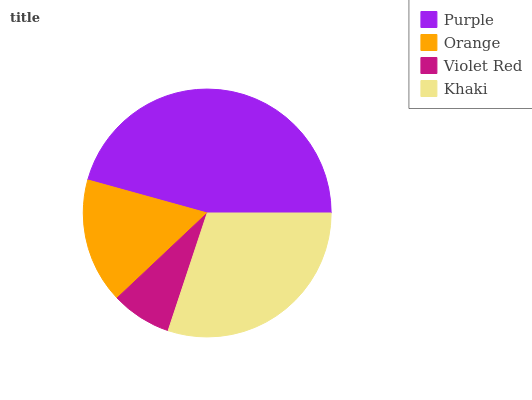Is Violet Red the minimum?
Answer yes or no. Yes. Is Purple the maximum?
Answer yes or no. Yes. Is Orange the minimum?
Answer yes or no. No. Is Orange the maximum?
Answer yes or no. No. Is Purple greater than Orange?
Answer yes or no. Yes. Is Orange less than Purple?
Answer yes or no. Yes. Is Orange greater than Purple?
Answer yes or no. No. Is Purple less than Orange?
Answer yes or no. No. Is Khaki the high median?
Answer yes or no. Yes. Is Orange the low median?
Answer yes or no. Yes. Is Violet Red the high median?
Answer yes or no. No. Is Violet Red the low median?
Answer yes or no. No. 